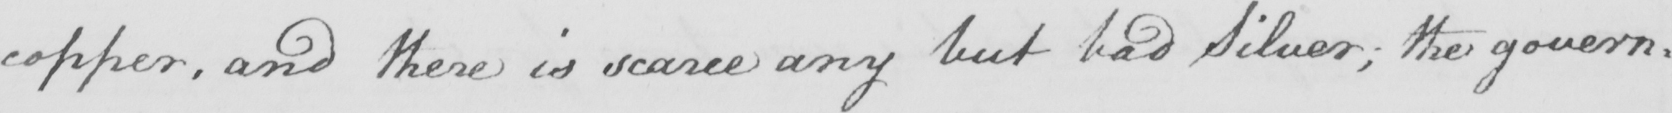What is written in this line of handwriting? copper , and there is scarce any but bad Silver ; the govern= 